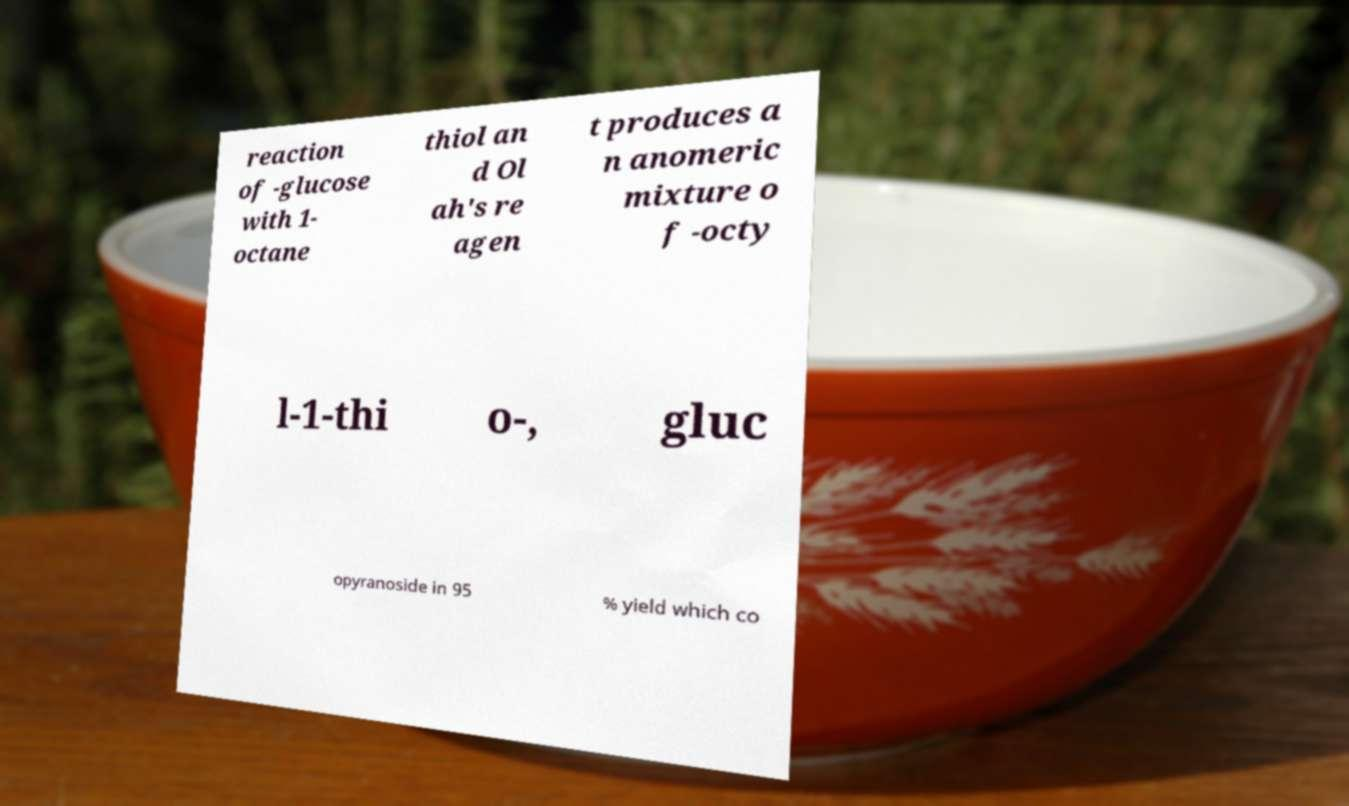For documentation purposes, I need the text within this image transcribed. Could you provide that? reaction of -glucose with 1- octane thiol an d Ol ah's re agen t produces a n anomeric mixture o f -octy l-1-thi o-, gluc opyranoside in 95 % yield which co 